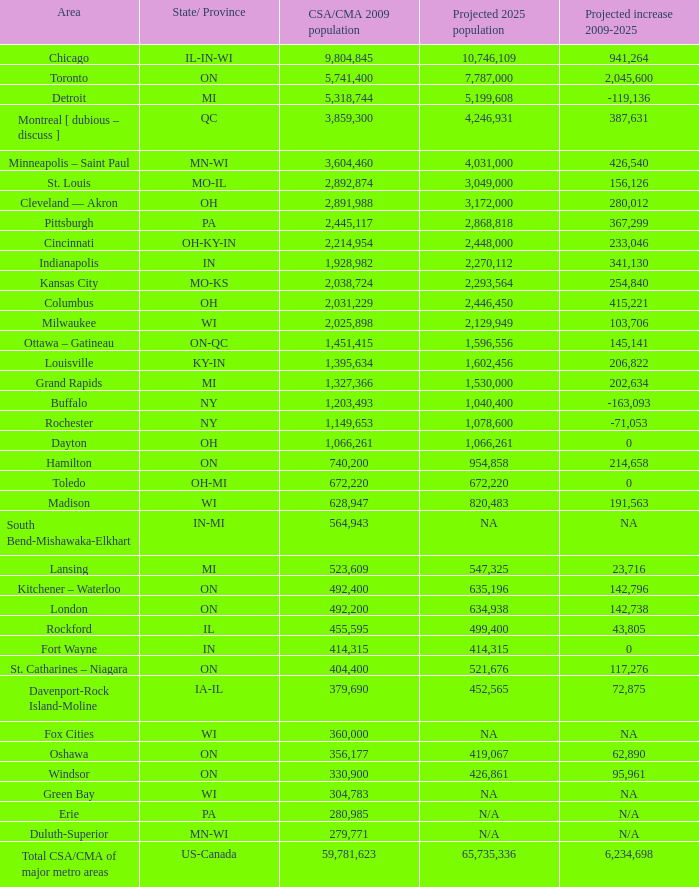What is the anticipated population size of in-mi? NA. 